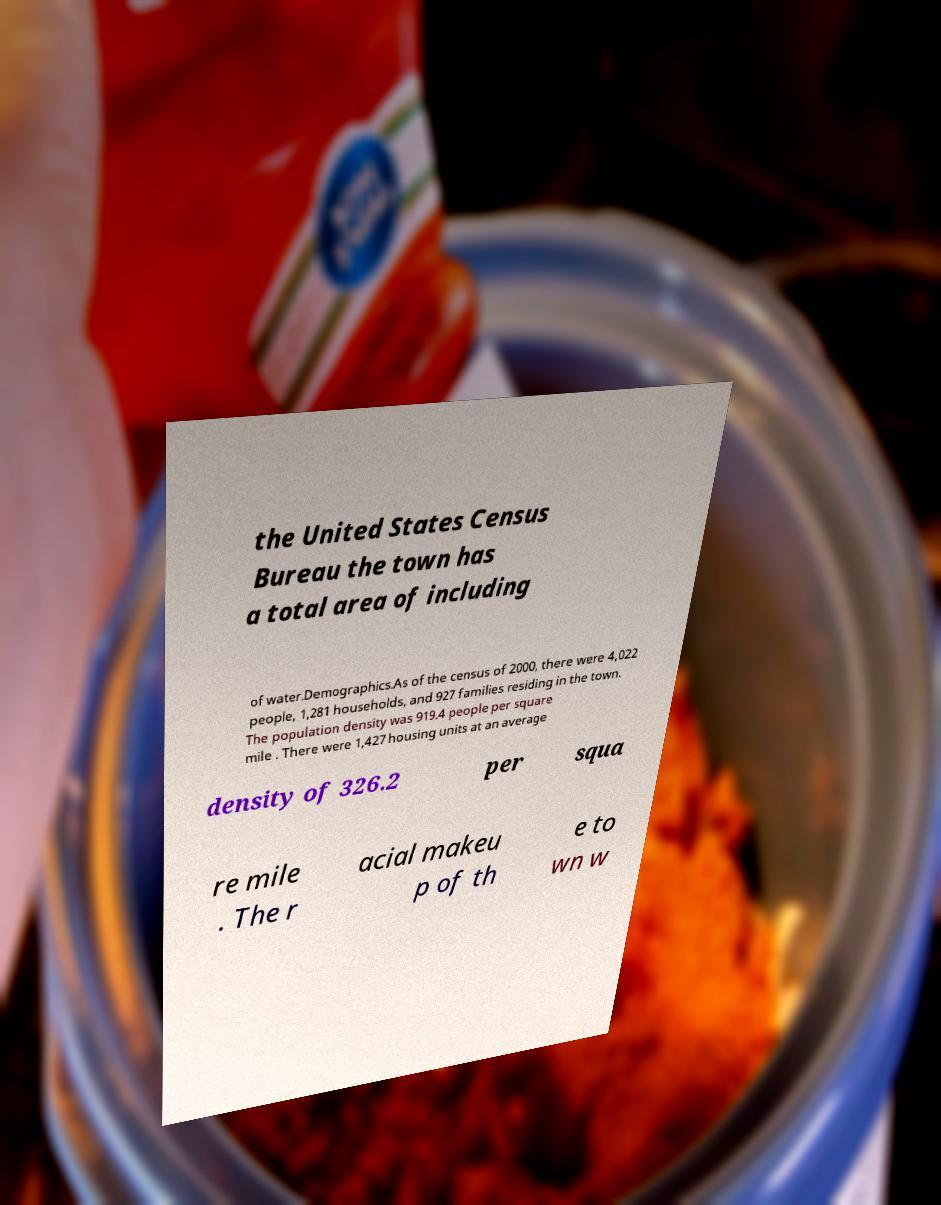I need the written content from this picture converted into text. Can you do that? the United States Census Bureau the town has a total area of including of water.Demographics.As of the census of 2000, there were 4,022 people, 1,281 households, and 927 families residing in the town. The population density was 919.4 people per square mile . There were 1,427 housing units at an average density of 326.2 per squa re mile . The r acial makeu p of th e to wn w 